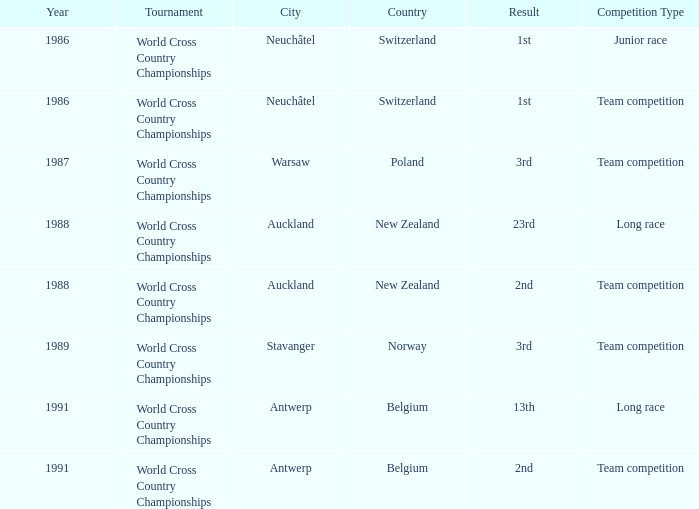Which venue had an extra of Junior Race? Neuchâtel , Switzerland. 